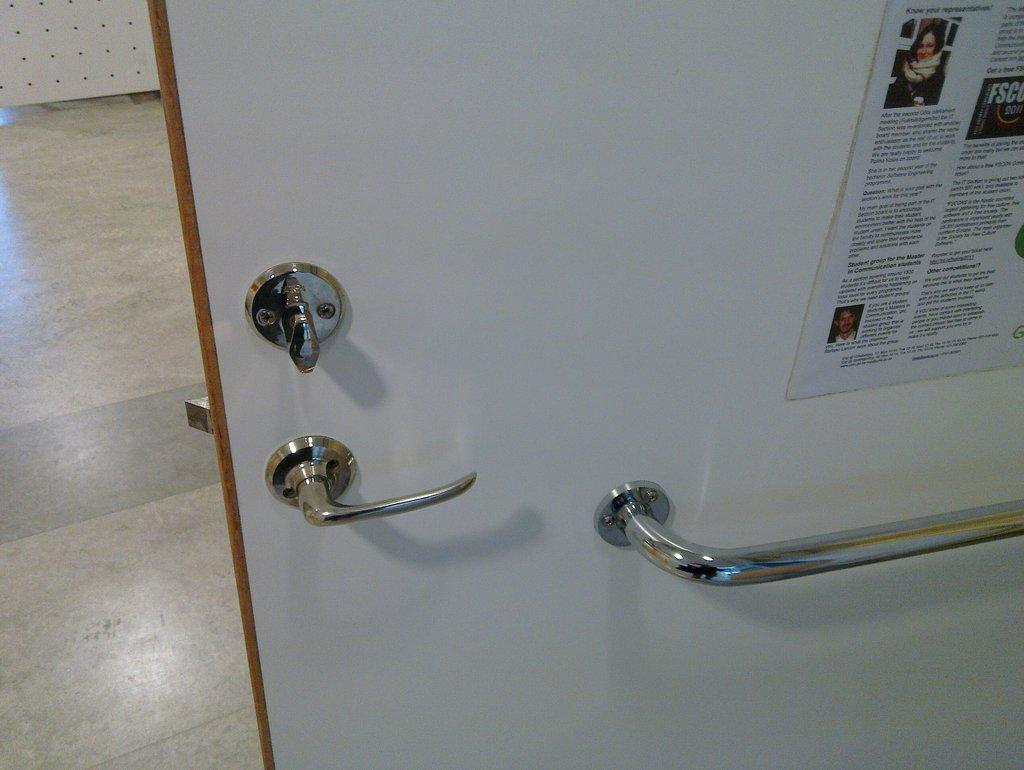What is located in the center of the image? There is a door in the center of the image. What feature does the door have? The door has handles. What is in the center of the image besides the door? There is a paper in the center of the image. What can be seen on the left side of the image? There is a floor and a board on the left side of the image. How many trucks are parked on the floor in the image? There are no trucks present in the image; it features a door, handles, paper, floor, and board. What type of locket is hanging from the board in the image? There is no locket present in the image; it only features a door, handles, paper, floor, and board. 